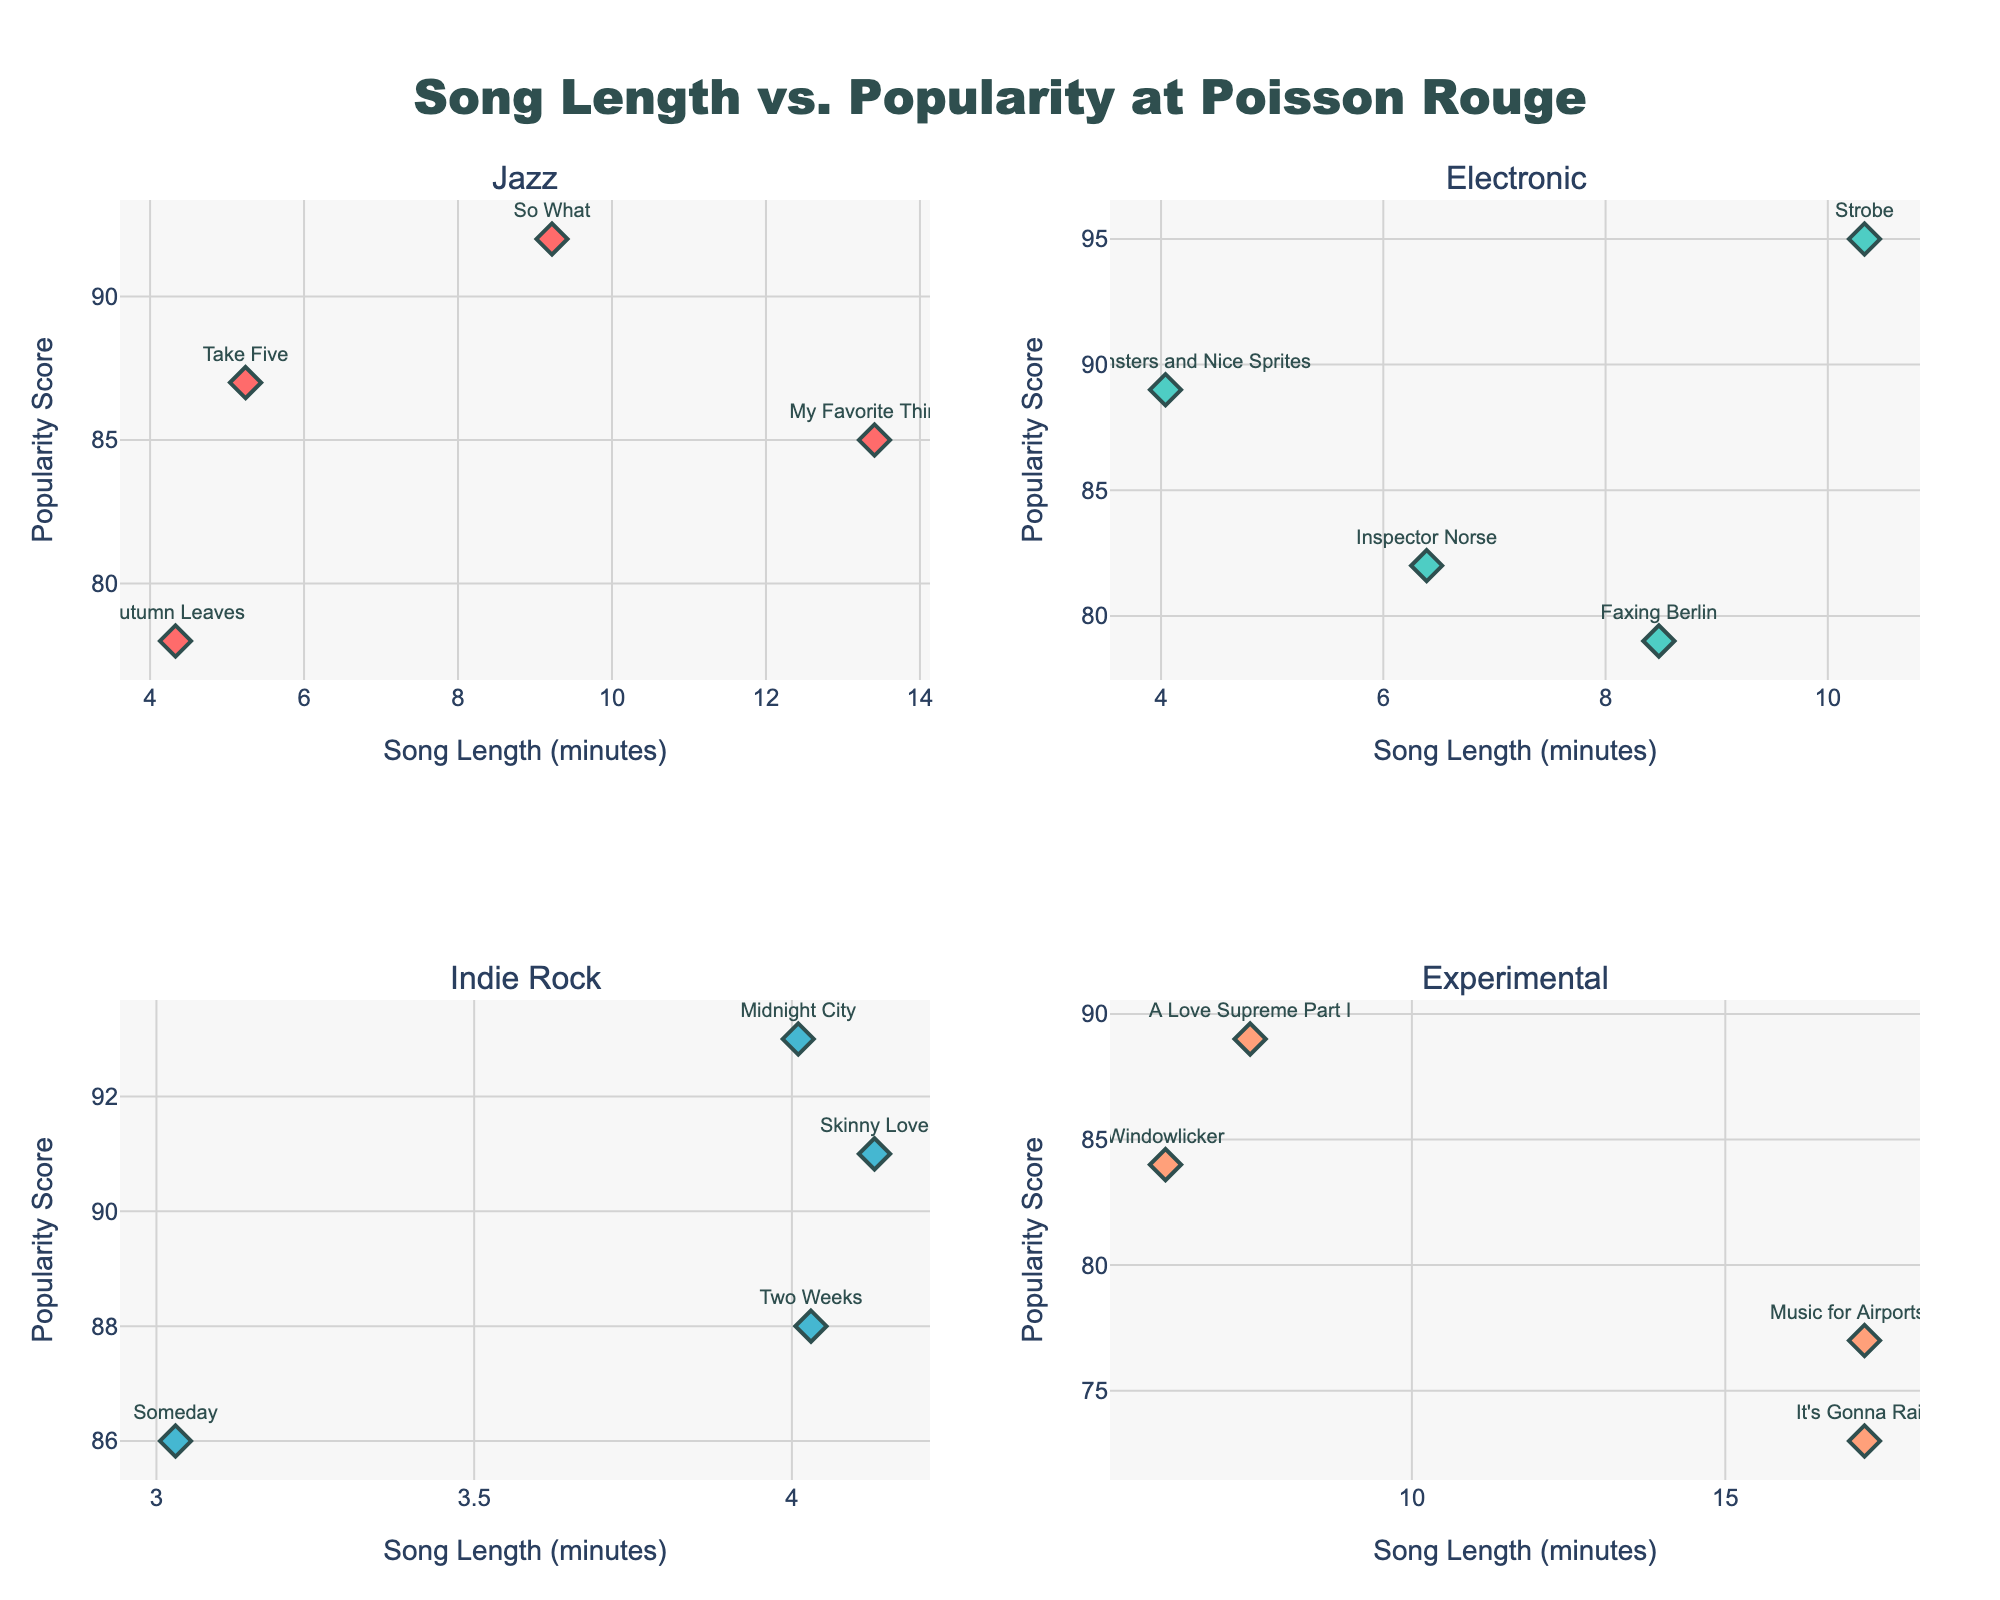What's the title of the figure? The title of the plot is displayed prominently at the top and can be read directly from the figure.
Answer: Song Length vs. Popularity at Poisson Rouge What does the x-axis represent? The label of the x-axis, which appears along the horizontal axis of each subplot, indicates the variable that is being measured.
Answer: Song Length (minutes) What genre has the longest average song length? Calculate the average song length for each genre by summing the song lengths and dividing by the number of songs in each genre, then compare the averages. Jazz: (5.24 + 9.22 + 4.33 + 13.41) / 4 = 8.05, Electronic: (10.33 + 4.04 + 6.39 + 8.48) / 4 = 7.31, Indie Rock: (4.13 + 4.03 + 4.01 + 3.03) / 4 = 3.8, Experimental: (6.07 + 17.22 + 7.42 + 17.22) / 4 = 11.98.
Answer: Experimental Which song has the highest popularity score? Locate the data point with the highest y-value across all subplots and check the corresponding song name shown as text on the plot.
Answer: Midnight City Are the points marked by symbols or lines? By visually inspecting the plot, observe the type of markers used for data points; distinguish whether they are symbols or lines.
Answer: Symbols (diamonds) Which genre has the most songs with a popularity score above 85? Count the number of data points with y-values (popularity scores) above 85 in each genre's subplot and compare. Jazz: 2, Electronic: 2, Indie Rock: 4, Experimental: 1.
Answer: Indie Rock What is the relationship between song lengths and popularity in the Jazz genre? By visual inspection, observe the trend or correlation (if any) between the x-values (song lengths) and y-values (popularity scores) within the Jazz subplot.
Answer: Slightly positive correlation For the song "It's Gonna Rain," what is its length and popularity score? Refer to the text shown in the Experimental subplot for "It's Gonna Rain" which displays its length and popularity score.
Answer: 17.22 min, 73 How many songs have a length greater than 10 minutes? Count the data points with x-values (lengths) greater than 10 across all subplots. Jazz: 1, Electronic: 1, Indie Rock: 0, Experimental: 3.
Answer: 5 